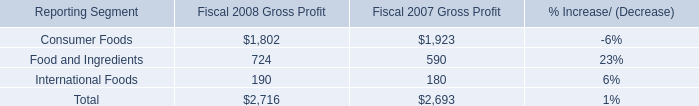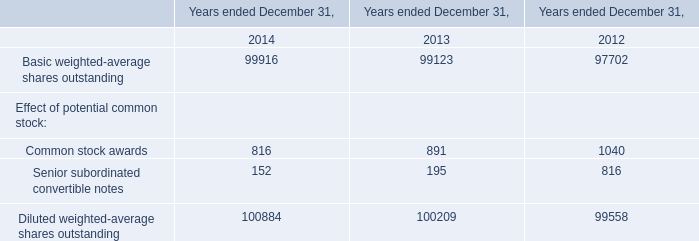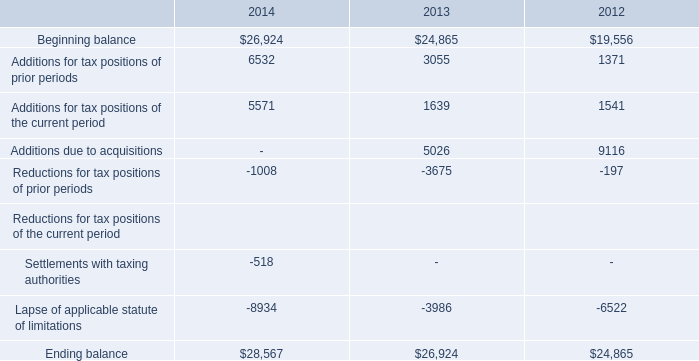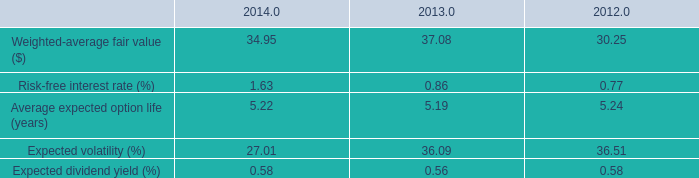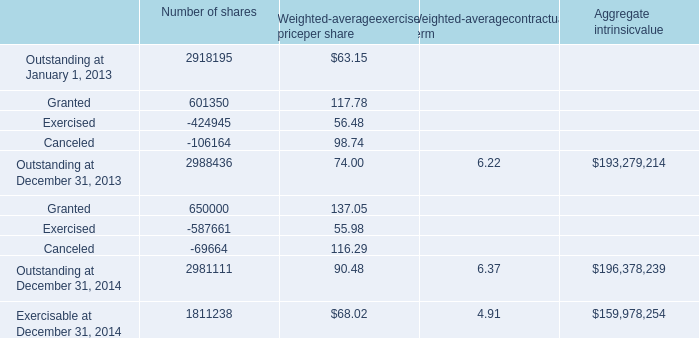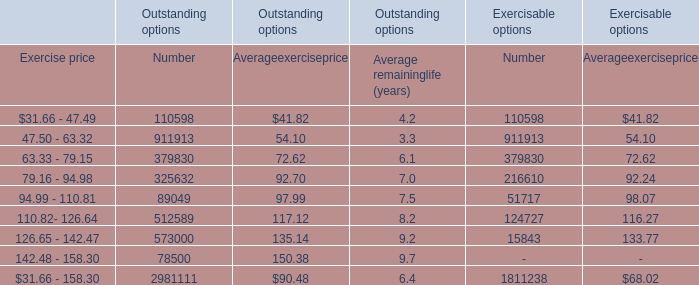What's the growth rate of Weighted-average fair value ($) in 2014? 
Computations: ((34.95 - 37.08) / 37.08)
Answer: -0.05744. 